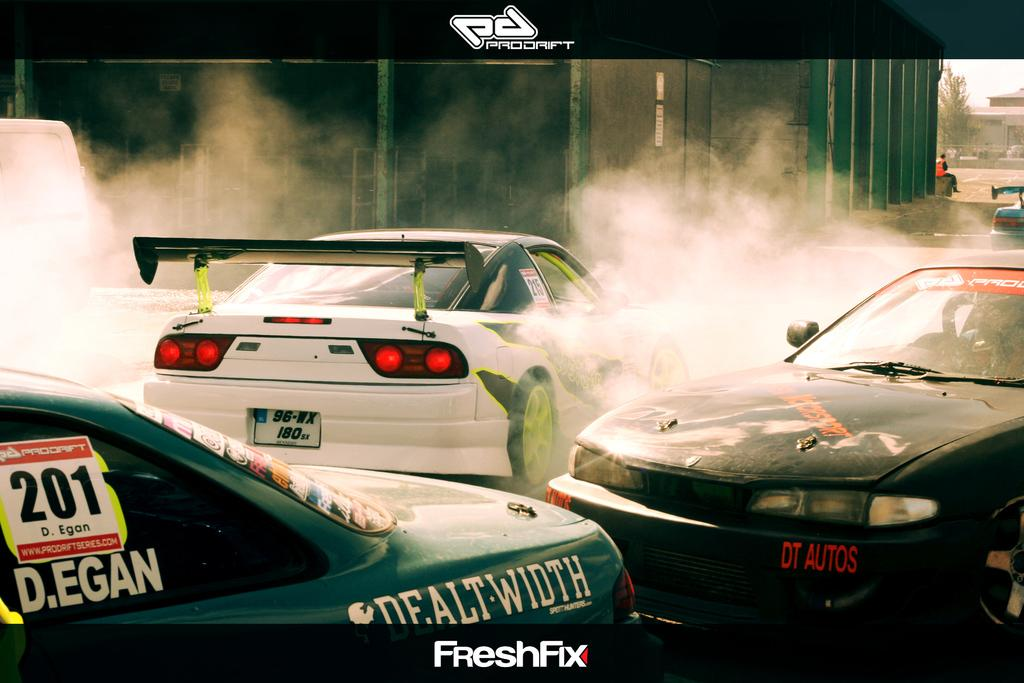What type of vehicles are in the image? There are three sports cars in the image. What else can be seen in the image besides the sports cars? There is smoke visible in the image. What is the color of the wall in the background of the image? The wall in the background of the image is black. What letters are being balanced on the spade in the image? There is no spade or letters present in the image. 